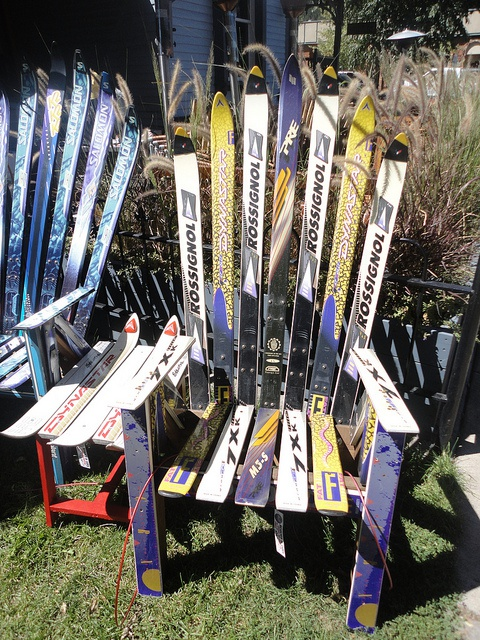Describe the objects in this image and their specific colors. I can see chair in black, white, gray, and darkgray tones, skis in black, white, gray, and darkgray tones, skis in black, white, gray, and khaki tones, skis in black, white, gray, and khaki tones, and skis in black, white, navy, and gray tones in this image. 